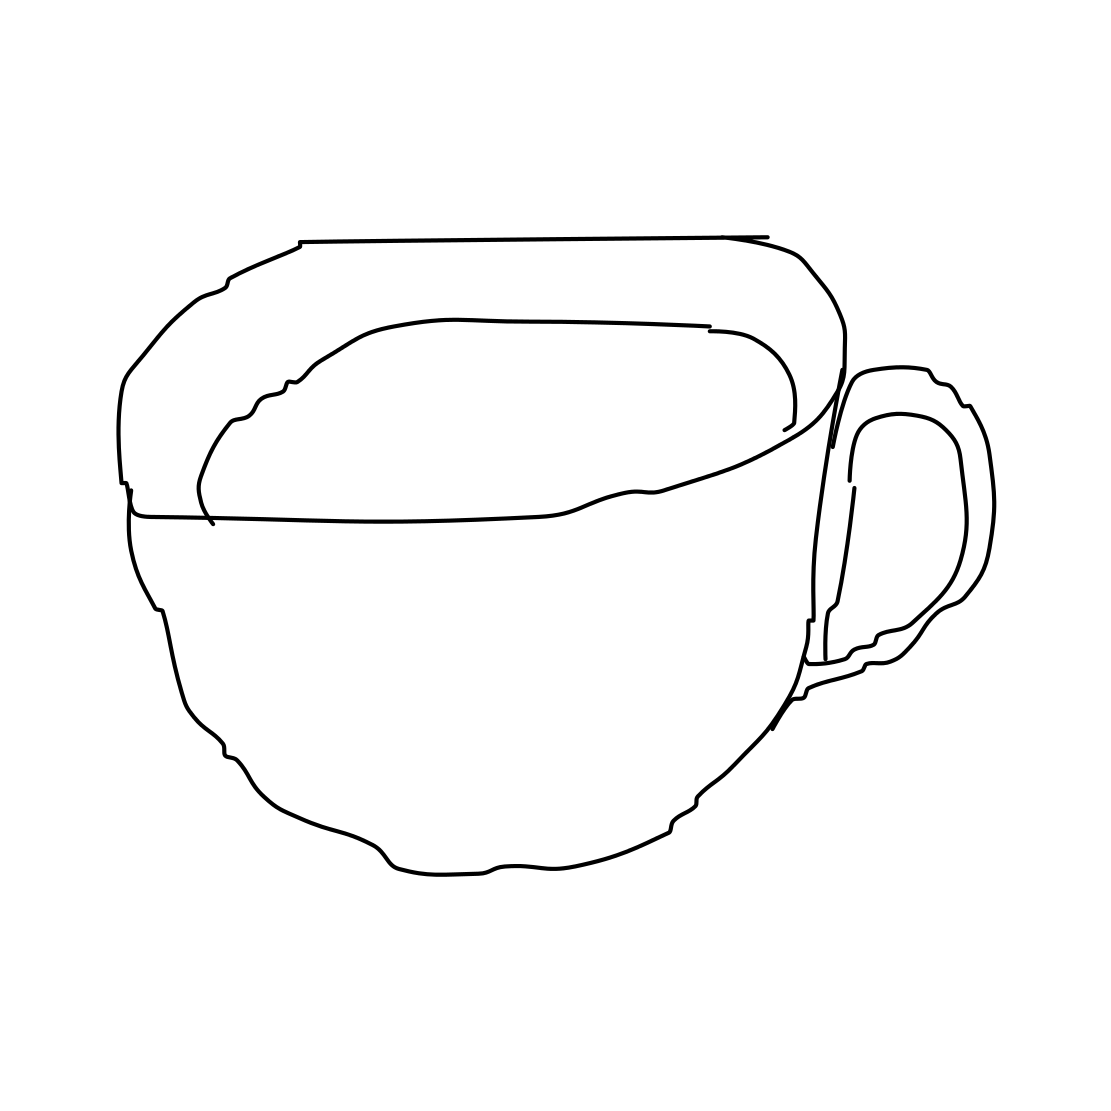Is this style of drawing common in any specific applications? Yes, line drawings like this are common in instructional materials, minimalist art, and coloring books for children and adults. It's used for its clarity, ease of reproduction, and its versatile aesthetic that can be adapted to various purposes. 